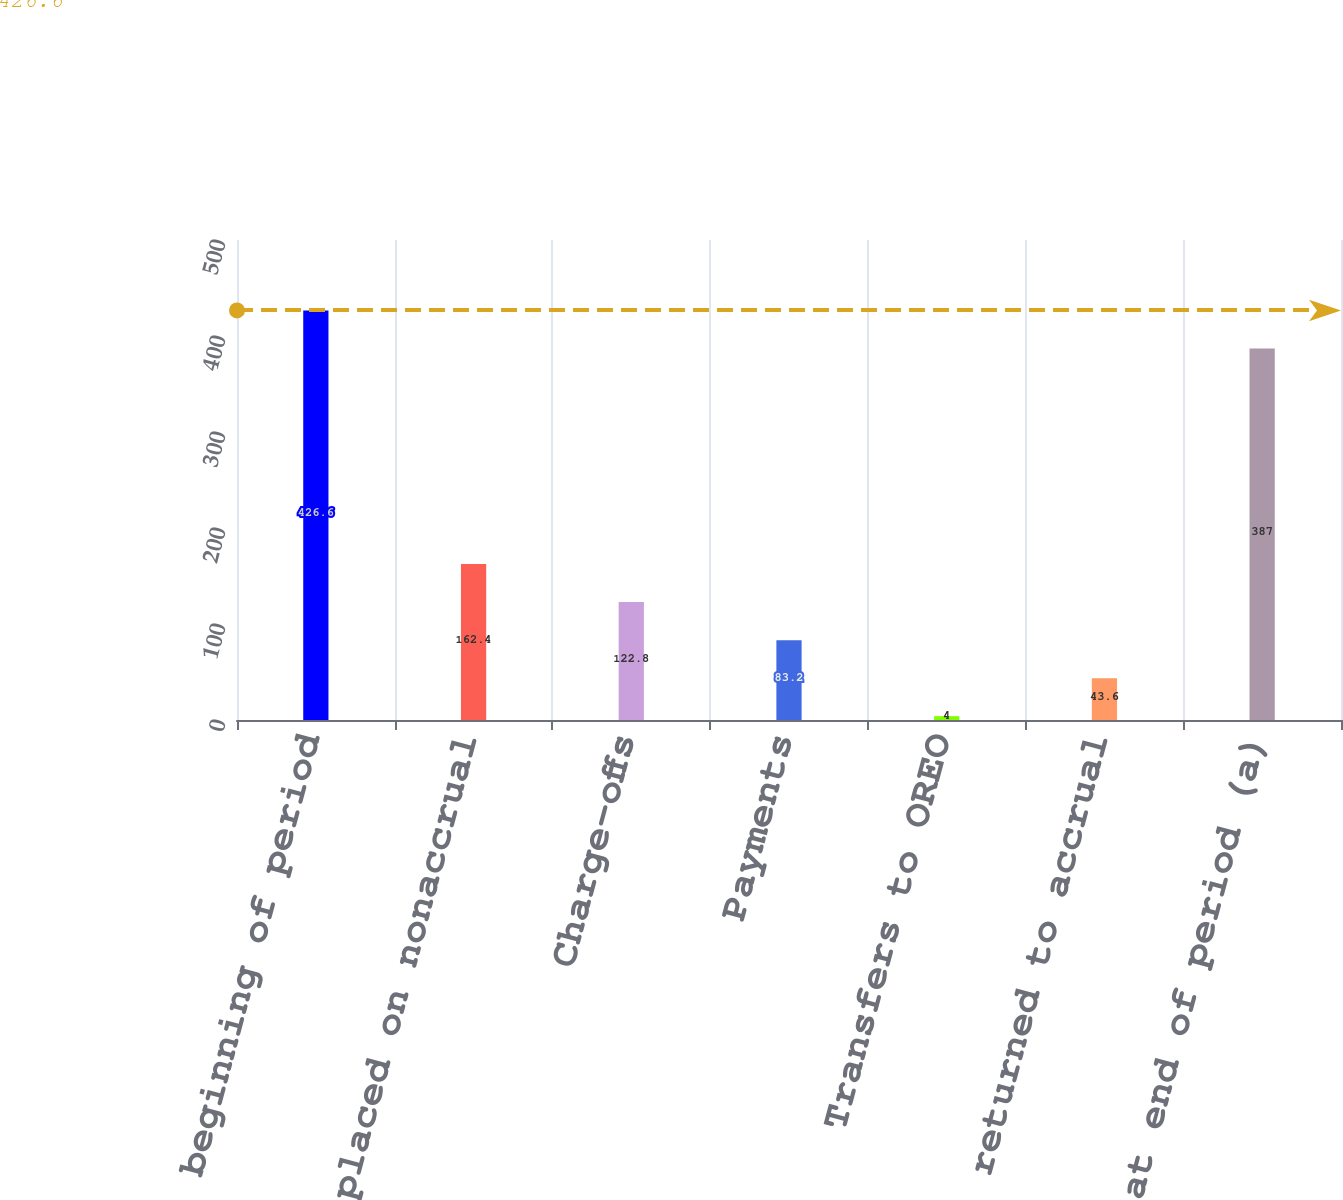Convert chart to OTSL. <chart><loc_0><loc_0><loc_500><loc_500><bar_chart><fcel>Balance at beginning of period<fcel>Loans placed on nonaccrual<fcel>Charge-offs<fcel>Payments<fcel>Transfers to OREO<fcel>Loans returned to accrual<fcel>Balance at end of period (a)<nl><fcel>426.6<fcel>162.4<fcel>122.8<fcel>83.2<fcel>4<fcel>43.6<fcel>387<nl></chart> 